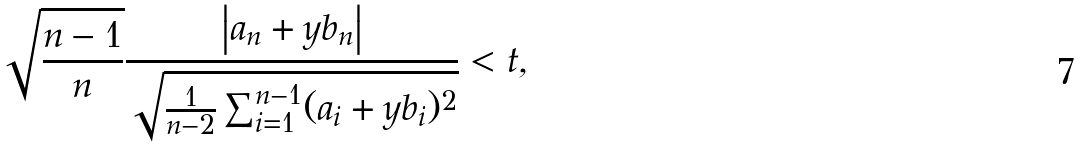Convert formula to latex. <formula><loc_0><loc_0><loc_500><loc_500>\sqrt { \frac { n - 1 } { n } } \frac { \left | a _ { n } + y b _ { n } \right | } { \sqrt { \frac { 1 } { n - 2 } \sum _ { i = 1 } ^ { n - 1 } ( a _ { i } + y b _ { i } ) ^ { 2 } } } < t ,</formula> 